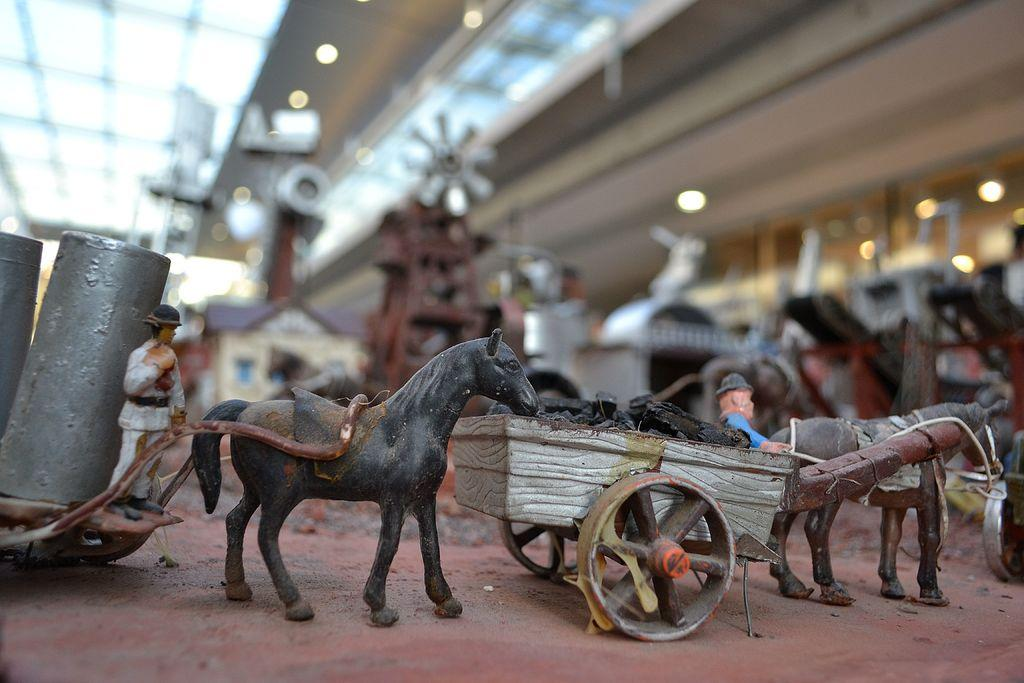What type of objects can be seen in the image? There are toy models in the image. Can you describe the background of the image? The background of the image is blurred. Where can you buy celery in the image? There is no store or celery present in the image. 